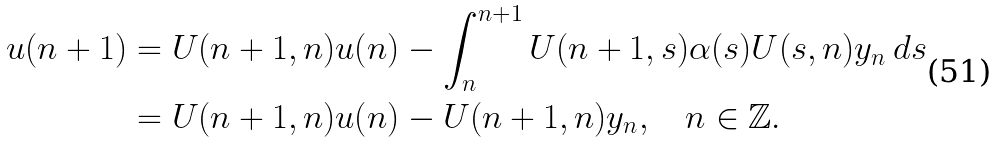Convert formula to latex. <formula><loc_0><loc_0><loc_500><loc_500>u ( n + 1 ) & = U ( n + 1 , n ) u ( n ) - \int ^ { n + 1 } _ { n } U ( n + 1 , s ) \alpha ( s ) U ( s , n ) y _ { n } \, d s \\ & = U ( n + 1 , n ) u ( n ) - U ( n + 1 , n ) y _ { n } , \quad n \in \mathbb { Z } .</formula> 